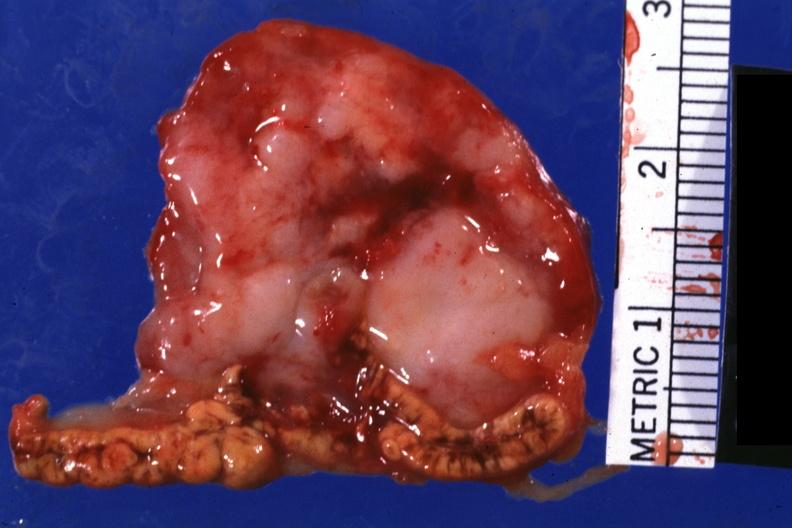where does this belong to?
Answer the question using a single word or phrase. Endocrine system 